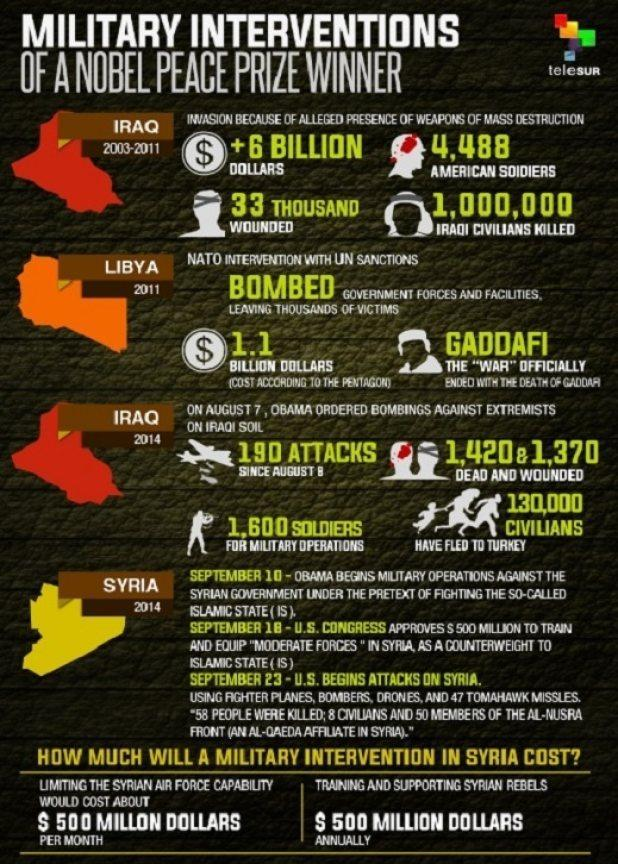How many American soldiers were killed in Iraq invasion during 2003-2011?
Answer the question with a short phrase. 4,488 What is the total number of dead & wounded people in Iraq bombing against extremists in 2014? 2790 How many soldiers were deployed for military operations in Iraq in 2014? 1,600 SOLDIERS 